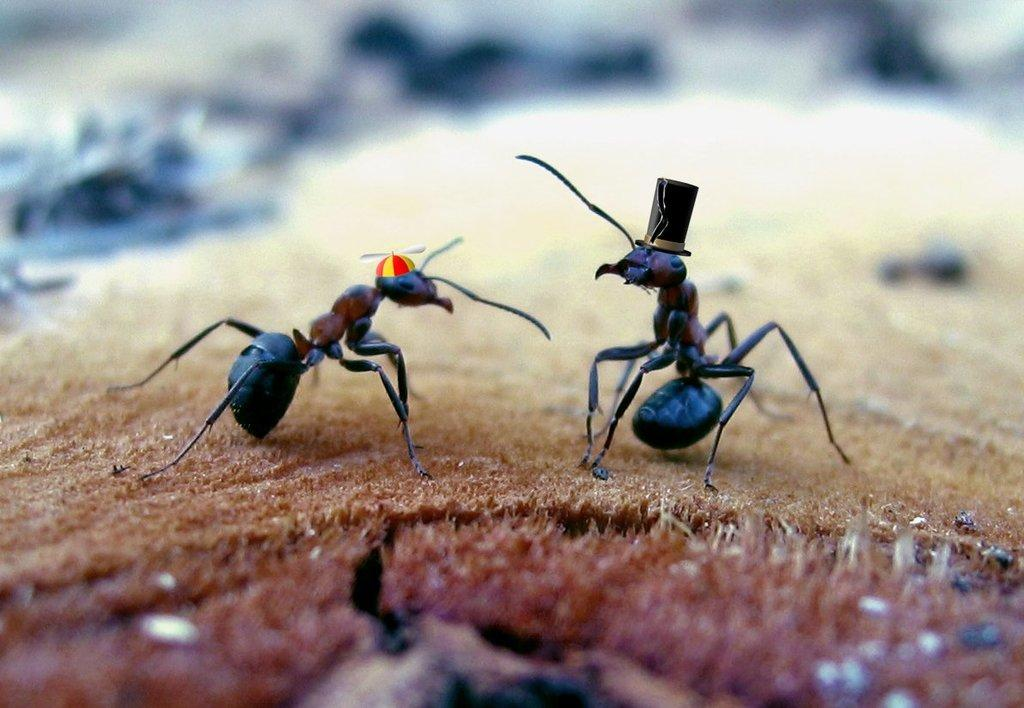What type of creatures can be seen on the surface in the image? There are ants on the surface in the image. What else is visible in the image besides the ants? There are caps visible in the image. How many eyes do the ants have in the image? The number of eyes the ants have cannot be determined from the image alone. What is the weight of the caps in the image? The weight of the caps cannot be determined from the image alone. 